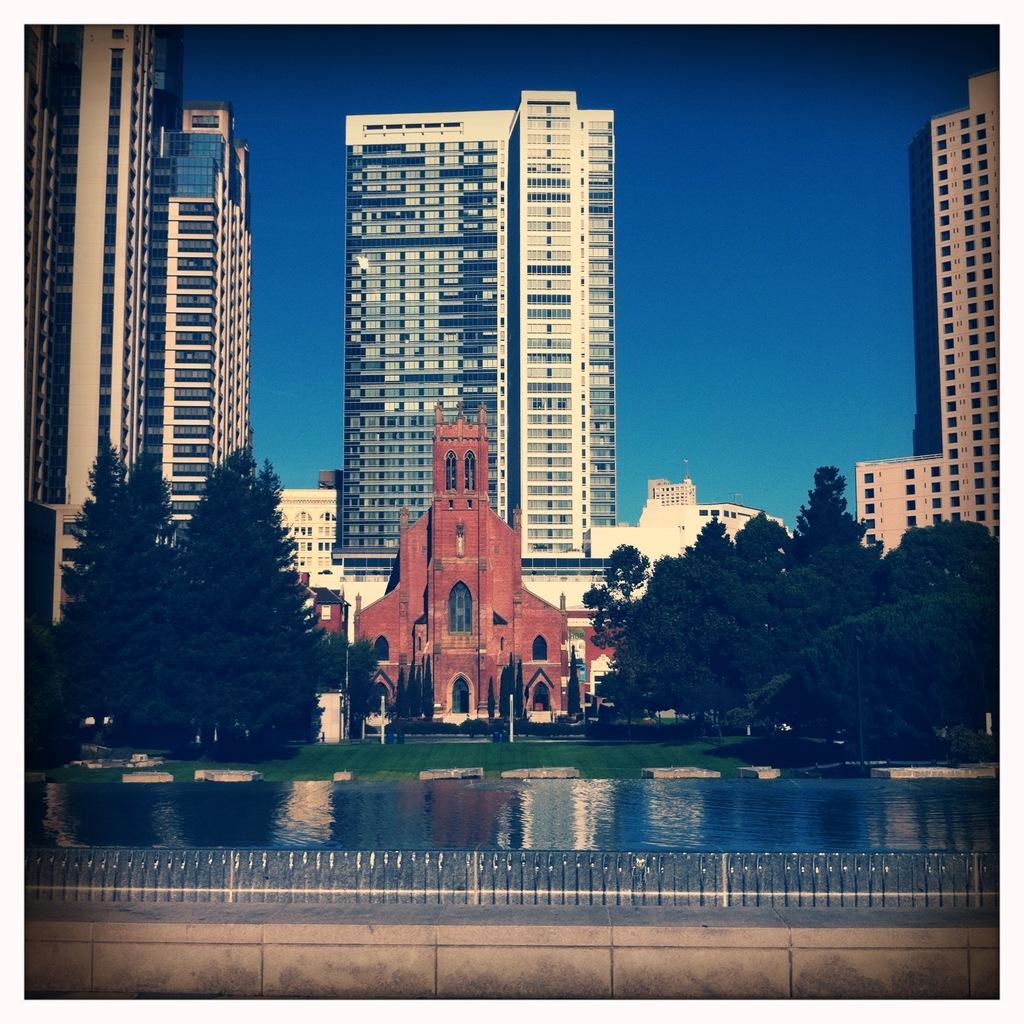Describe this image in one or two sentences. In the background we can see the sky and skyscrapers and a building. On the right and the left side of the picture we can see trees. We can see water, grass and the fence. 